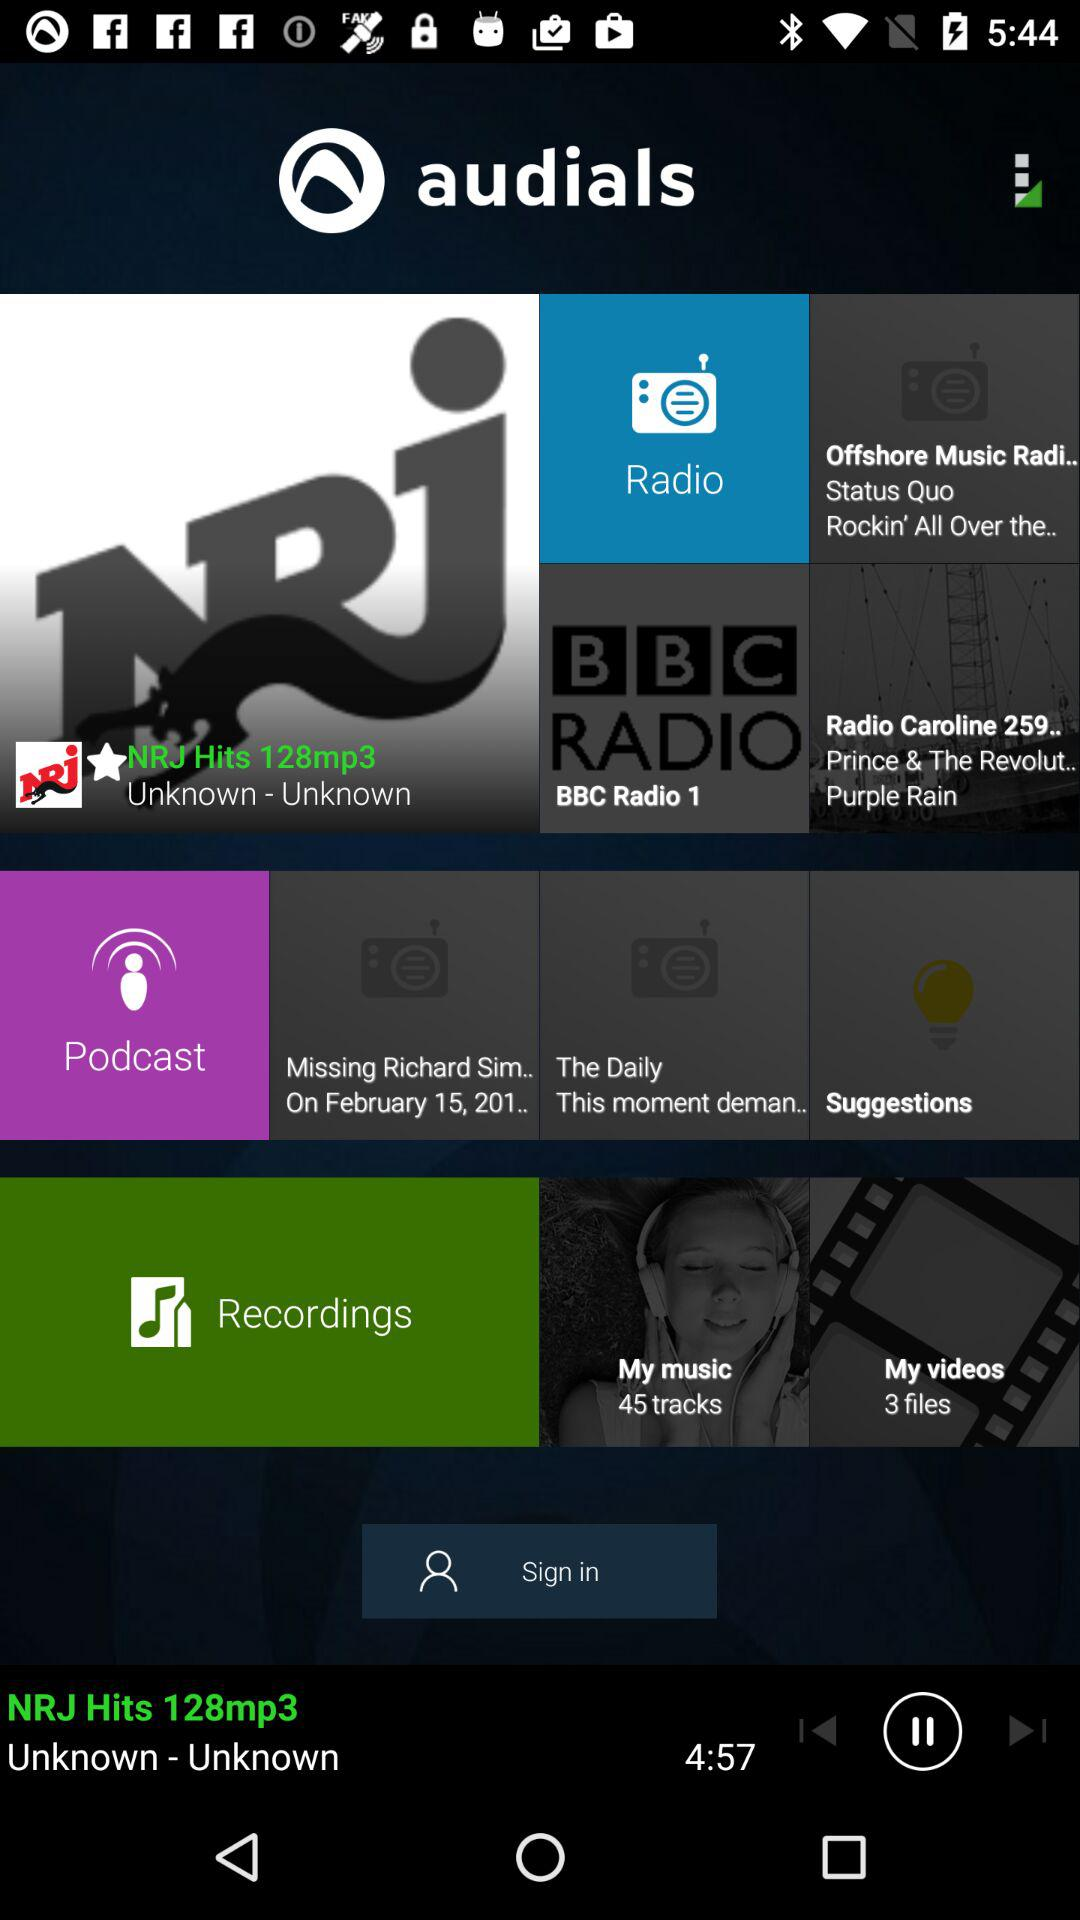What are the different options available in "Podcast"? The available options are "Missing Richard Sim... On February 15, 201.." and "The Daily This moment deman..". 